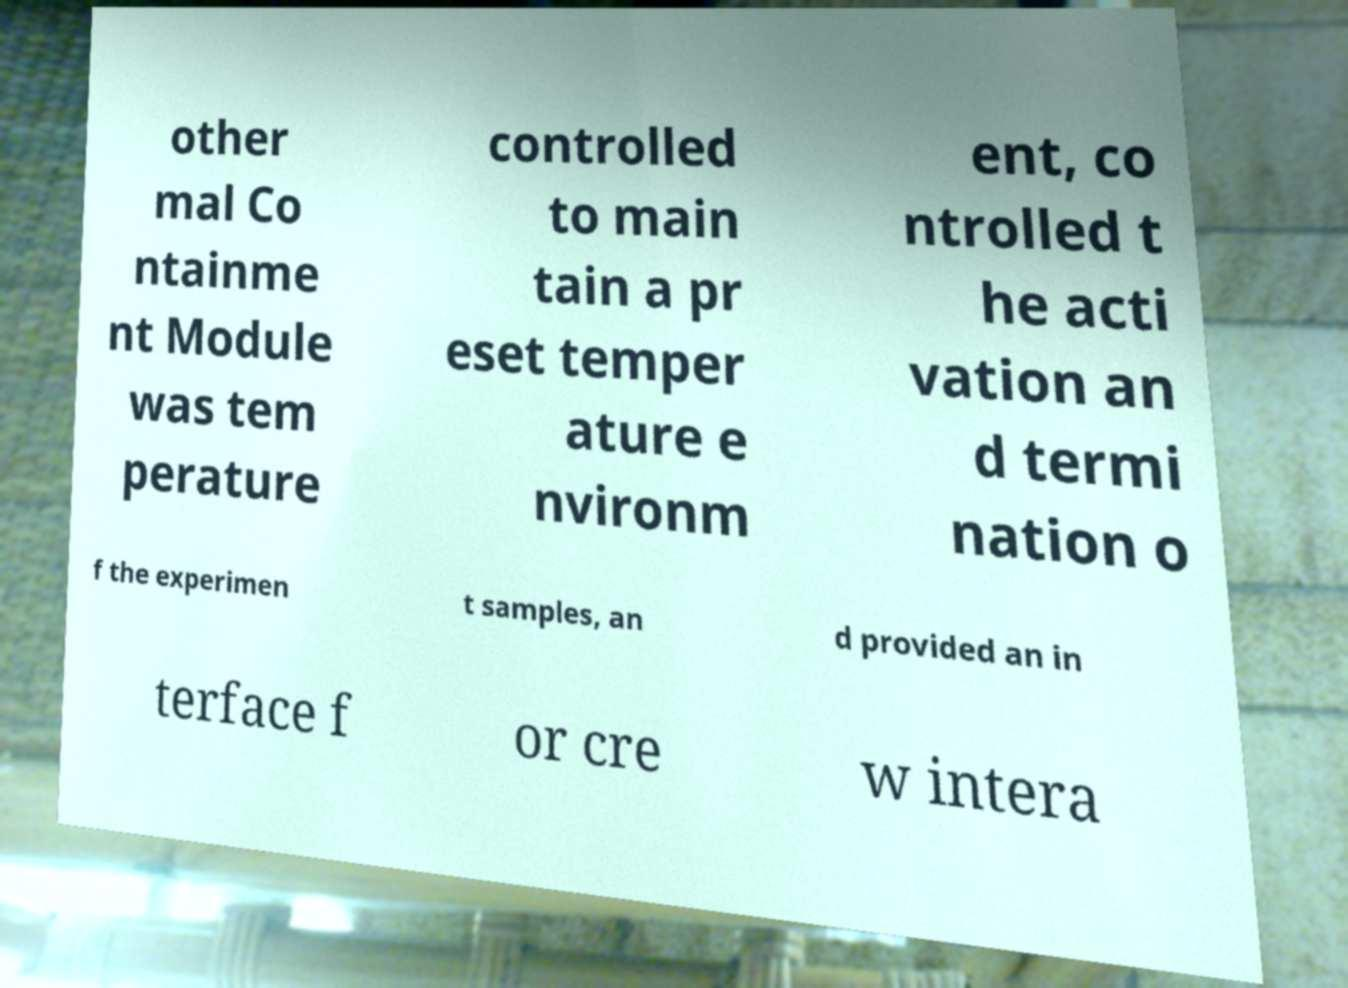I need the written content from this picture converted into text. Can you do that? other mal Co ntainme nt Module was tem perature controlled to main tain a pr eset temper ature e nvironm ent, co ntrolled t he acti vation an d termi nation o f the experimen t samples, an d provided an in terface f or cre w intera 